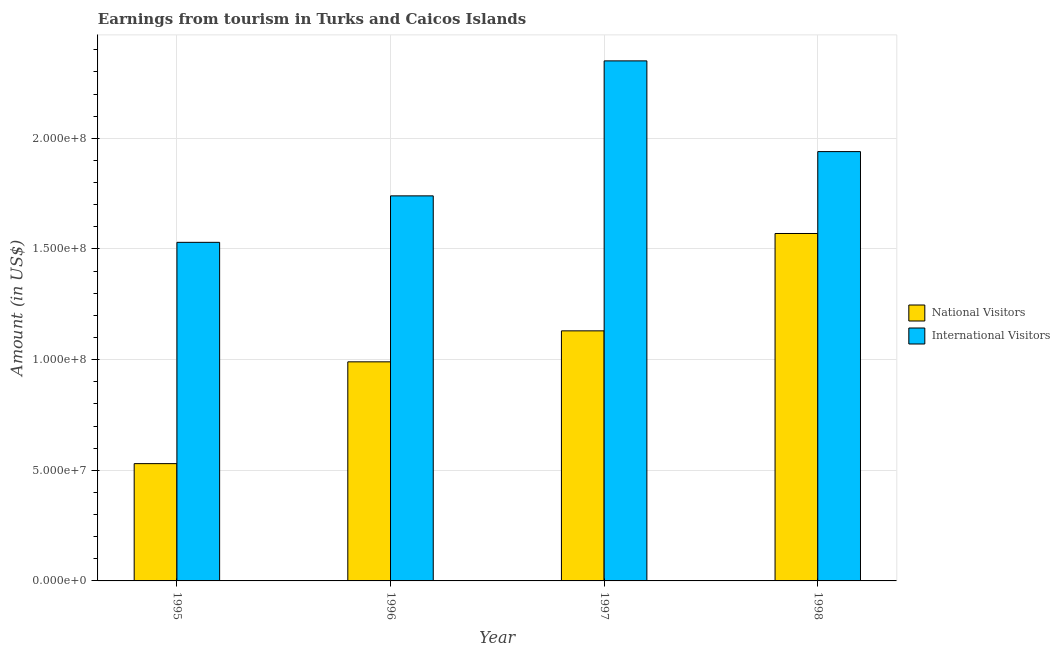How many bars are there on the 4th tick from the left?
Keep it short and to the point. 2. How many bars are there on the 1st tick from the right?
Keep it short and to the point. 2. In how many cases, is the number of bars for a given year not equal to the number of legend labels?
Provide a succinct answer. 0. What is the amount earned from national visitors in 1995?
Provide a short and direct response. 5.30e+07. Across all years, what is the maximum amount earned from national visitors?
Keep it short and to the point. 1.57e+08. Across all years, what is the minimum amount earned from international visitors?
Give a very brief answer. 1.53e+08. What is the total amount earned from international visitors in the graph?
Offer a terse response. 7.56e+08. What is the difference between the amount earned from national visitors in 1996 and that in 1998?
Your response must be concise. -5.80e+07. What is the difference between the amount earned from international visitors in 1997 and the amount earned from national visitors in 1996?
Your response must be concise. 6.10e+07. What is the average amount earned from international visitors per year?
Provide a succinct answer. 1.89e+08. In the year 1996, what is the difference between the amount earned from national visitors and amount earned from international visitors?
Give a very brief answer. 0. What is the ratio of the amount earned from international visitors in 1996 to that in 1997?
Keep it short and to the point. 0.74. Is the amount earned from national visitors in 1997 less than that in 1998?
Give a very brief answer. Yes. What is the difference between the highest and the second highest amount earned from national visitors?
Keep it short and to the point. 4.40e+07. What is the difference between the highest and the lowest amount earned from international visitors?
Provide a succinct answer. 8.20e+07. Is the sum of the amount earned from international visitors in 1995 and 1996 greater than the maximum amount earned from national visitors across all years?
Your response must be concise. Yes. What does the 2nd bar from the left in 1998 represents?
Offer a terse response. International Visitors. What does the 2nd bar from the right in 1997 represents?
Your response must be concise. National Visitors. How many bars are there?
Your response must be concise. 8. Are all the bars in the graph horizontal?
Offer a terse response. No. Does the graph contain any zero values?
Make the answer very short. No. Where does the legend appear in the graph?
Give a very brief answer. Center right. How many legend labels are there?
Your response must be concise. 2. What is the title of the graph?
Your response must be concise. Earnings from tourism in Turks and Caicos Islands. What is the label or title of the X-axis?
Offer a terse response. Year. What is the label or title of the Y-axis?
Provide a short and direct response. Amount (in US$). What is the Amount (in US$) of National Visitors in 1995?
Provide a succinct answer. 5.30e+07. What is the Amount (in US$) in International Visitors in 1995?
Offer a terse response. 1.53e+08. What is the Amount (in US$) of National Visitors in 1996?
Provide a succinct answer. 9.90e+07. What is the Amount (in US$) in International Visitors in 1996?
Your answer should be very brief. 1.74e+08. What is the Amount (in US$) in National Visitors in 1997?
Make the answer very short. 1.13e+08. What is the Amount (in US$) of International Visitors in 1997?
Make the answer very short. 2.35e+08. What is the Amount (in US$) in National Visitors in 1998?
Ensure brevity in your answer.  1.57e+08. What is the Amount (in US$) of International Visitors in 1998?
Offer a terse response. 1.94e+08. Across all years, what is the maximum Amount (in US$) of National Visitors?
Give a very brief answer. 1.57e+08. Across all years, what is the maximum Amount (in US$) of International Visitors?
Provide a succinct answer. 2.35e+08. Across all years, what is the minimum Amount (in US$) of National Visitors?
Make the answer very short. 5.30e+07. Across all years, what is the minimum Amount (in US$) in International Visitors?
Offer a terse response. 1.53e+08. What is the total Amount (in US$) in National Visitors in the graph?
Offer a very short reply. 4.22e+08. What is the total Amount (in US$) of International Visitors in the graph?
Provide a short and direct response. 7.56e+08. What is the difference between the Amount (in US$) of National Visitors in 1995 and that in 1996?
Keep it short and to the point. -4.60e+07. What is the difference between the Amount (in US$) of International Visitors in 1995 and that in 1996?
Ensure brevity in your answer.  -2.10e+07. What is the difference between the Amount (in US$) in National Visitors in 1995 and that in 1997?
Provide a short and direct response. -6.00e+07. What is the difference between the Amount (in US$) of International Visitors in 1995 and that in 1997?
Your answer should be very brief. -8.20e+07. What is the difference between the Amount (in US$) in National Visitors in 1995 and that in 1998?
Your answer should be very brief. -1.04e+08. What is the difference between the Amount (in US$) in International Visitors in 1995 and that in 1998?
Keep it short and to the point. -4.10e+07. What is the difference between the Amount (in US$) of National Visitors in 1996 and that in 1997?
Provide a succinct answer. -1.40e+07. What is the difference between the Amount (in US$) of International Visitors in 1996 and that in 1997?
Provide a succinct answer. -6.10e+07. What is the difference between the Amount (in US$) in National Visitors in 1996 and that in 1998?
Your response must be concise. -5.80e+07. What is the difference between the Amount (in US$) of International Visitors in 1996 and that in 1998?
Provide a succinct answer. -2.00e+07. What is the difference between the Amount (in US$) in National Visitors in 1997 and that in 1998?
Provide a short and direct response. -4.40e+07. What is the difference between the Amount (in US$) of International Visitors in 1997 and that in 1998?
Keep it short and to the point. 4.10e+07. What is the difference between the Amount (in US$) in National Visitors in 1995 and the Amount (in US$) in International Visitors in 1996?
Your answer should be very brief. -1.21e+08. What is the difference between the Amount (in US$) of National Visitors in 1995 and the Amount (in US$) of International Visitors in 1997?
Your answer should be compact. -1.82e+08. What is the difference between the Amount (in US$) in National Visitors in 1995 and the Amount (in US$) in International Visitors in 1998?
Offer a very short reply. -1.41e+08. What is the difference between the Amount (in US$) in National Visitors in 1996 and the Amount (in US$) in International Visitors in 1997?
Your answer should be very brief. -1.36e+08. What is the difference between the Amount (in US$) in National Visitors in 1996 and the Amount (in US$) in International Visitors in 1998?
Your answer should be very brief. -9.50e+07. What is the difference between the Amount (in US$) in National Visitors in 1997 and the Amount (in US$) in International Visitors in 1998?
Your answer should be very brief. -8.10e+07. What is the average Amount (in US$) in National Visitors per year?
Your answer should be compact. 1.06e+08. What is the average Amount (in US$) of International Visitors per year?
Your answer should be compact. 1.89e+08. In the year 1995, what is the difference between the Amount (in US$) of National Visitors and Amount (in US$) of International Visitors?
Provide a short and direct response. -1.00e+08. In the year 1996, what is the difference between the Amount (in US$) in National Visitors and Amount (in US$) in International Visitors?
Provide a short and direct response. -7.50e+07. In the year 1997, what is the difference between the Amount (in US$) of National Visitors and Amount (in US$) of International Visitors?
Your answer should be very brief. -1.22e+08. In the year 1998, what is the difference between the Amount (in US$) in National Visitors and Amount (in US$) in International Visitors?
Keep it short and to the point. -3.70e+07. What is the ratio of the Amount (in US$) of National Visitors in 1995 to that in 1996?
Your answer should be very brief. 0.54. What is the ratio of the Amount (in US$) in International Visitors in 1995 to that in 1996?
Keep it short and to the point. 0.88. What is the ratio of the Amount (in US$) of National Visitors in 1995 to that in 1997?
Your response must be concise. 0.47. What is the ratio of the Amount (in US$) of International Visitors in 1995 to that in 1997?
Your answer should be compact. 0.65. What is the ratio of the Amount (in US$) in National Visitors in 1995 to that in 1998?
Make the answer very short. 0.34. What is the ratio of the Amount (in US$) in International Visitors in 1995 to that in 1998?
Give a very brief answer. 0.79. What is the ratio of the Amount (in US$) of National Visitors in 1996 to that in 1997?
Make the answer very short. 0.88. What is the ratio of the Amount (in US$) of International Visitors in 1996 to that in 1997?
Your response must be concise. 0.74. What is the ratio of the Amount (in US$) in National Visitors in 1996 to that in 1998?
Your answer should be compact. 0.63. What is the ratio of the Amount (in US$) of International Visitors in 1996 to that in 1998?
Keep it short and to the point. 0.9. What is the ratio of the Amount (in US$) in National Visitors in 1997 to that in 1998?
Make the answer very short. 0.72. What is the ratio of the Amount (in US$) in International Visitors in 1997 to that in 1998?
Make the answer very short. 1.21. What is the difference between the highest and the second highest Amount (in US$) in National Visitors?
Offer a terse response. 4.40e+07. What is the difference between the highest and the second highest Amount (in US$) in International Visitors?
Your answer should be very brief. 4.10e+07. What is the difference between the highest and the lowest Amount (in US$) in National Visitors?
Ensure brevity in your answer.  1.04e+08. What is the difference between the highest and the lowest Amount (in US$) in International Visitors?
Offer a terse response. 8.20e+07. 